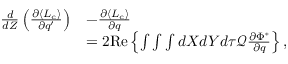<formula> <loc_0><loc_0><loc_500><loc_500>\begin{array} { r l } { \frac { d } { d Z } \left ( \frac { \partial \langle L _ { c } \rangle } { \partial q ^ { \prime } } \right ) } & { - \frac { \partial \langle L _ { c } \rangle } { \partial q } } \\ & { = 2 R e \left \{ \int \int \int d X d Y d \tau \mathcal { Q } \frac { \partial \Phi ^ { \ast } } { \partial q } \right \} , } \end{array}</formula> 